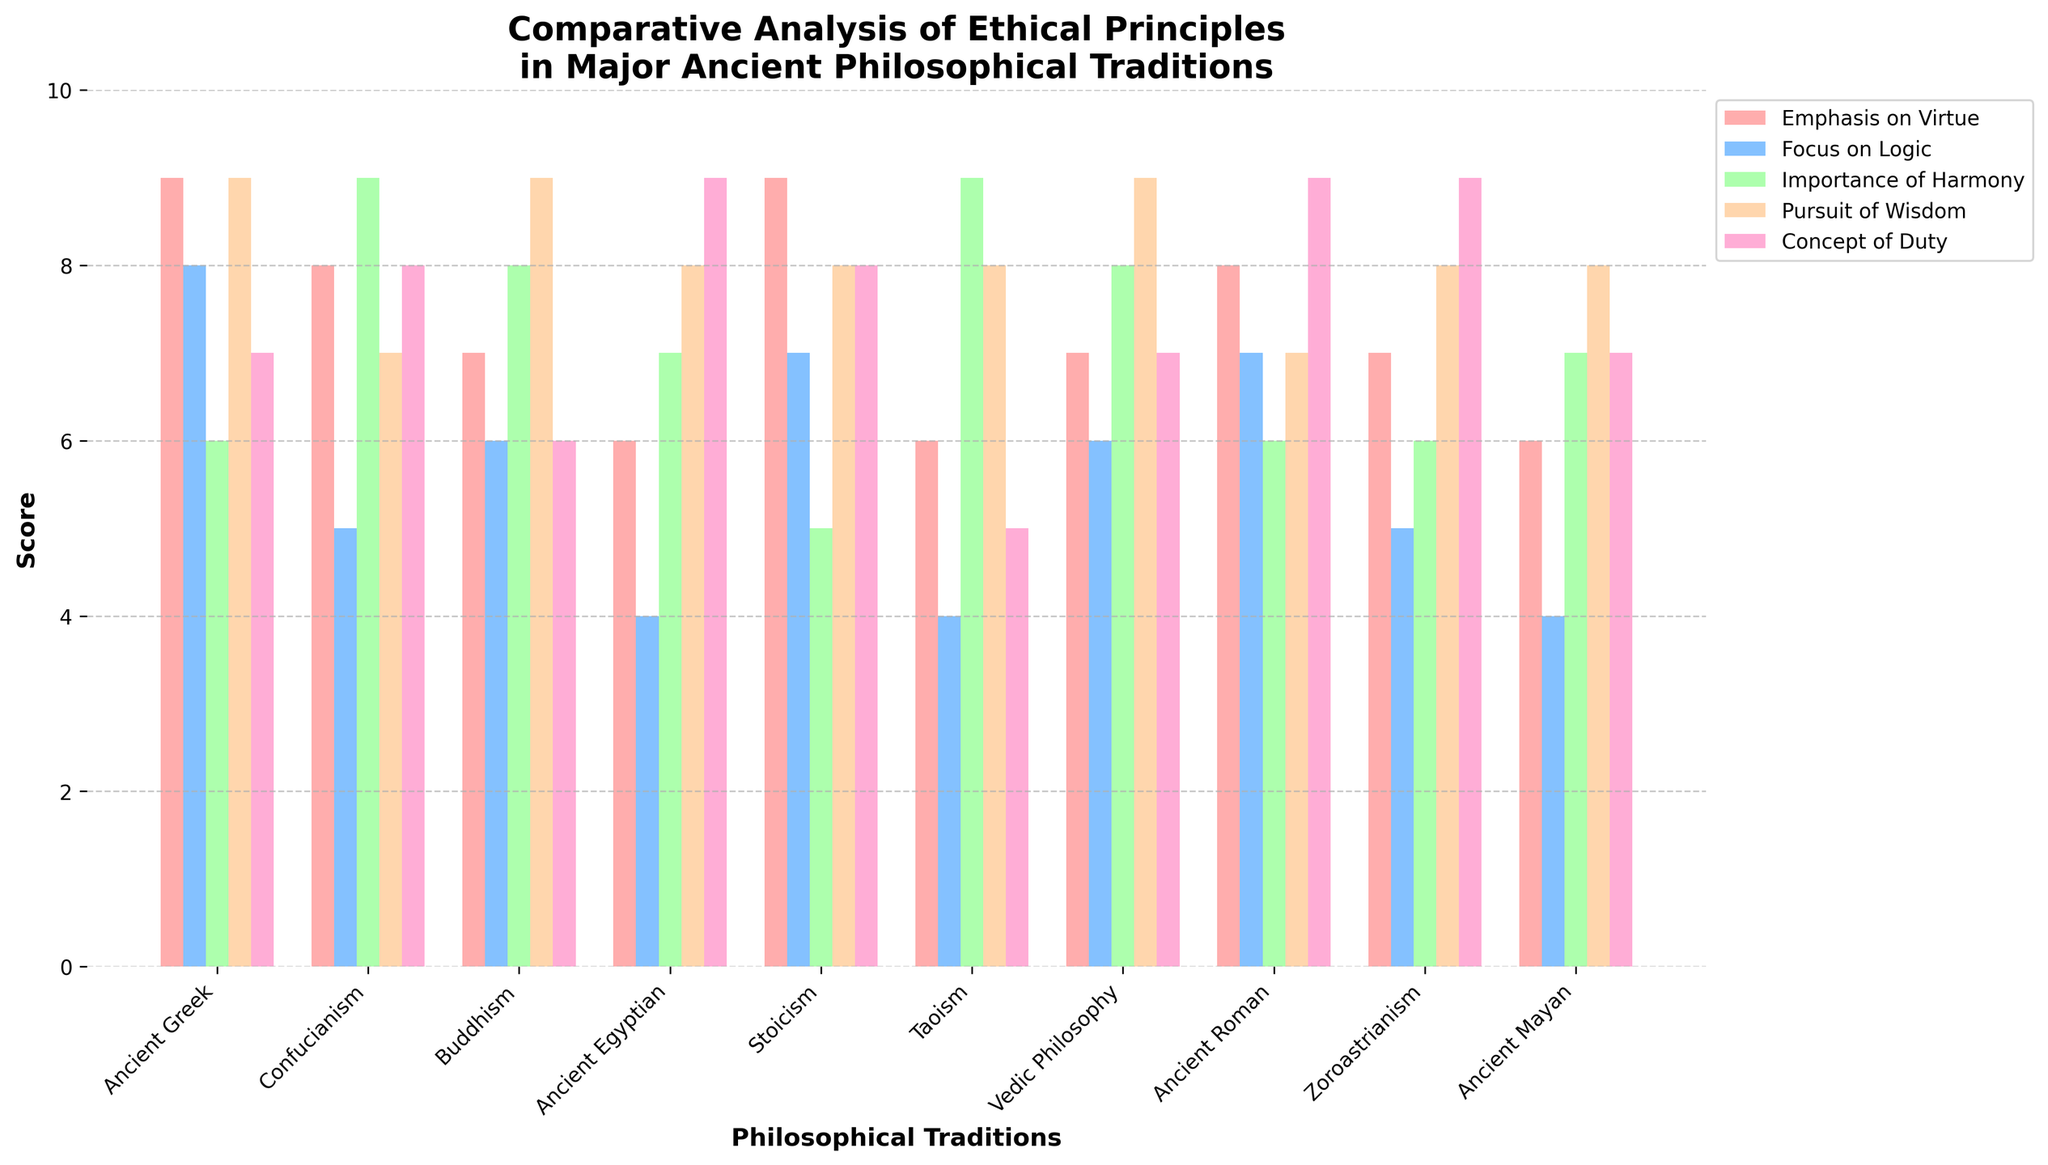Which philosophical tradition places the greatest emphasis on harmony? In the plot, the score for "Importance of Harmony" is represented by a bar for each tradition. By comparing the heights of these bars, Confucianism and Taoism have the highest at 9.
Answer: Confucianism and Taoism Which tradition has the lowest score in the "Focus on Logic" category? In the "Focus on Logic" category, we observe the smallest bar heights representing the scores for each tradition. Confucianism, Ancient Egyptian, Taoism, and Ancient Mayan all share the lowest score of 4.
Answer: Confucianism, Ancient Egyptian, Taoism, and Ancient Mayan On average, how does Buddhism compare to Stoicism across all ethical principles? To find the average score for Buddhism and Stoicism, sum their scores in each of the five categories and divide by 5. Buddhism: (7+6+8+9+6)/5 = 7.2, Stoicism: (9+7+5+8+8)/5 = 7.4.
Answer: Stoicism has a slightly higher average score What is the difference in the "Concept of Duty" score between Ancient Greek and Ancient Roman traditions? Locate the bars for Ancient Greek and Ancient Roman under the "Concept of Duty" category. Ancient Greek has a score of 7, and Ancient Roman has 9. The difference is 9 - 7.
Answer: 2 Which tradition has the widest variance in scores across the categories? Calculate the variance in scores for each tradition by determining the difference between the highest and lowest scores. Stoicism has scores of (9, 7, 5, 8, 8) with the widest range being 9 - 5 = 4.
Answer: Stoicism What is the total sum of scores for Vedic Philosophy across all categories? Sum the scores of Vedic Philosophy in each of the five categories: 7 + 6 + 8 + 9 + 7 = 37.
Answer: 37 Which philosophical tradition has a higher "Pursuit of Wisdom" score, Buddhism or Vedic Philosophy? Compare the "Pursuit of Wisdom" score, which is visually represented by bars, for Buddhism (9) and Vedic Philosophy (9). They have the same score.
Answer: They are equal Between Ancient Greek and Confucianism, which has a stronger emphasis on virtue? Compare the heights of the bars for "Emphasis on Virtue." The bar for Ancient Greek is 9, while Confucianism has 8.
Answer: Ancient Greek Which tradition balances the scores between "Emphasis on Virtue" and "Pursuit of Wisdom" most evenly? Look for traditions where the bars for "Emphasis on Virtue" and "Pursuit of Wisdom" are closest in height. For example, Vedic Philosophy has both scores as 7 and 9, respectively, maintaining a closer range.
Answer: Buddhism and Vedic Philosophy How do the "Importance of Harmony" scores for Taoism and Vedic Philosophy compare? Check the heights of "Importance of Harmony" bars for Taoism (9) and Vedic Philosophy (8).
Answer: Taoism has a higher score 